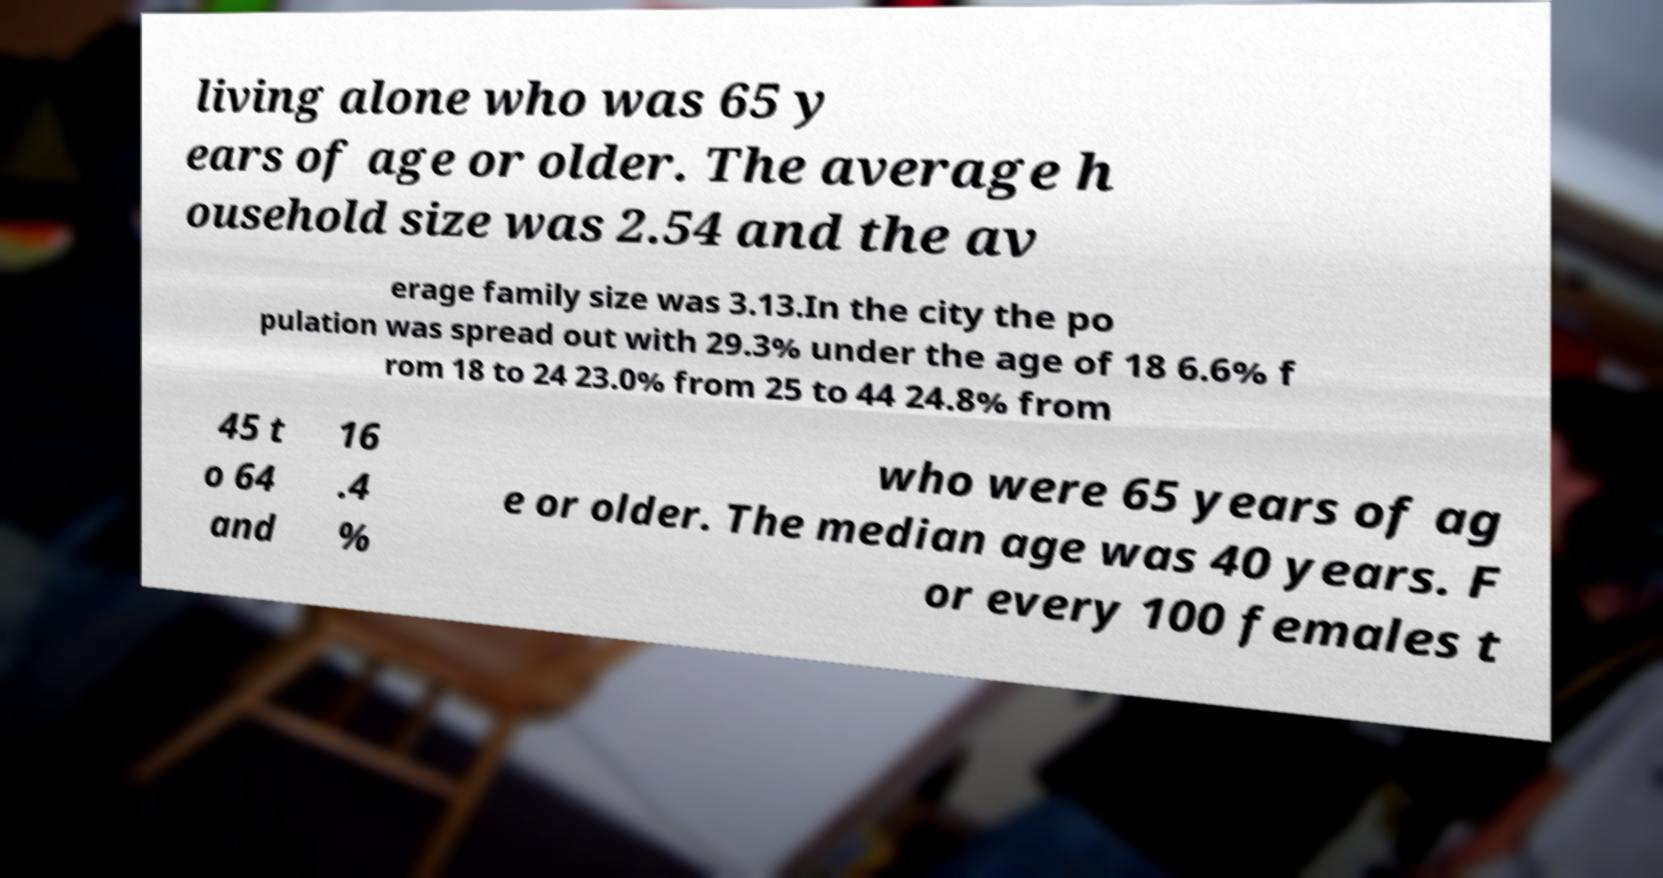Please identify and transcribe the text found in this image. living alone who was 65 y ears of age or older. The average h ousehold size was 2.54 and the av erage family size was 3.13.In the city the po pulation was spread out with 29.3% under the age of 18 6.6% f rom 18 to 24 23.0% from 25 to 44 24.8% from 45 t o 64 and 16 .4 % who were 65 years of ag e or older. The median age was 40 years. F or every 100 females t 